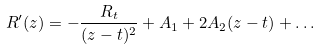Convert formula to latex. <formula><loc_0><loc_0><loc_500><loc_500>R ^ { \prime } ( z ) = - \frac { R _ { t } } { ( z - t ) ^ { 2 } } + A _ { 1 } + 2 A _ { 2 } ( z - t ) + \dots</formula> 